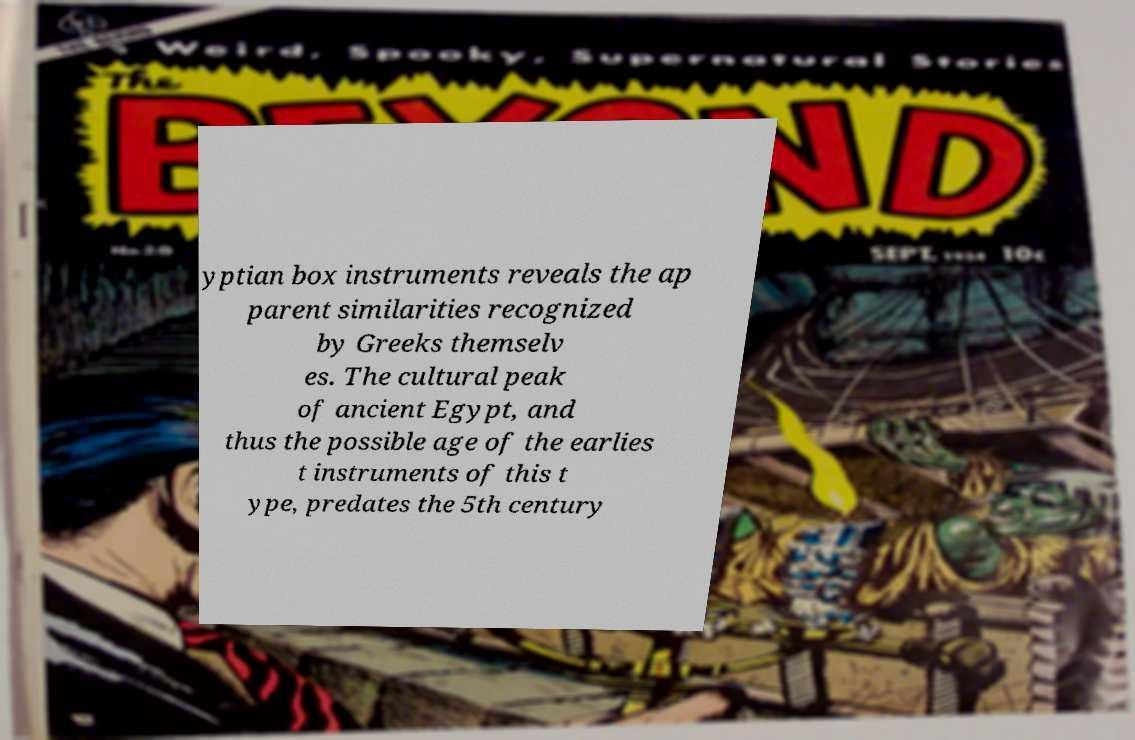Can you read and provide the text displayed in the image?This photo seems to have some interesting text. Can you extract and type it out for me? yptian box instruments reveals the ap parent similarities recognized by Greeks themselv es. The cultural peak of ancient Egypt, and thus the possible age of the earlies t instruments of this t ype, predates the 5th century 